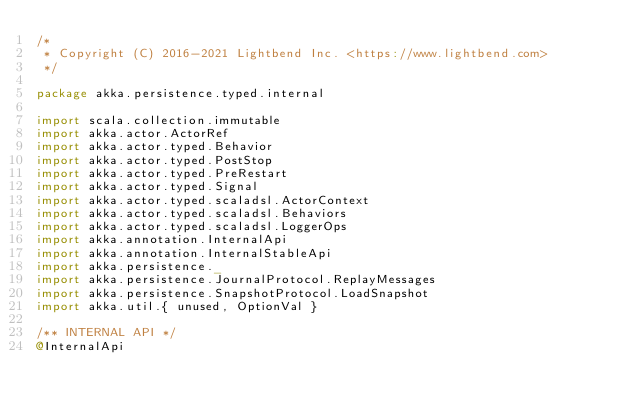<code> <loc_0><loc_0><loc_500><loc_500><_Scala_>/*
 * Copyright (C) 2016-2021 Lightbend Inc. <https://www.lightbend.com>
 */

package akka.persistence.typed.internal

import scala.collection.immutable
import akka.actor.ActorRef
import akka.actor.typed.Behavior
import akka.actor.typed.PostStop
import akka.actor.typed.PreRestart
import akka.actor.typed.Signal
import akka.actor.typed.scaladsl.ActorContext
import akka.actor.typed.scaladsl.Behaviors
import akka.actor.typed.scaladsl.LoggerOps
import akka.annotation.InternalApi
import akka.annotation.InternalStableApi
import akka.persistence._
import akka.persistence.JournalProtocol.ReplayMessages
import akka.persistence.SnapshotProtocol.LoadSnapshot
import akka.util.{ unused, OptionVal }

/** INTERNAL API */
@InternalApi</code> 